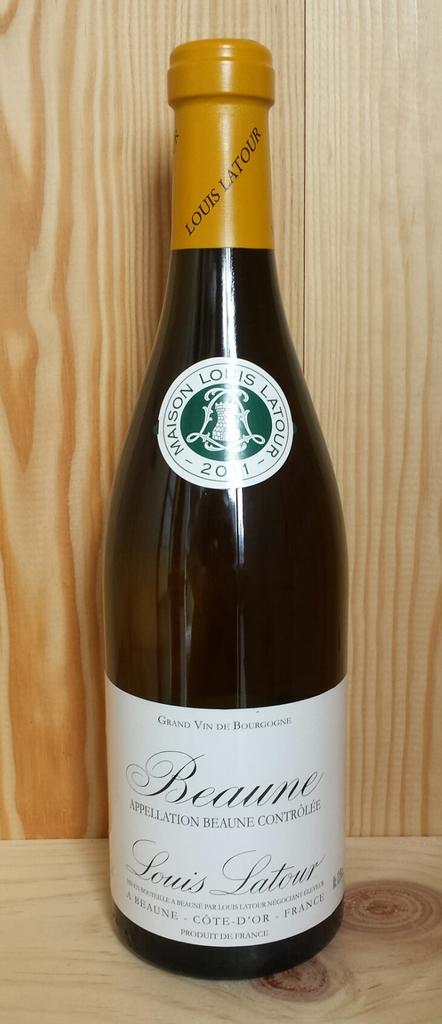What year is the wine?
Offer a very short reply. Unanswerable. 